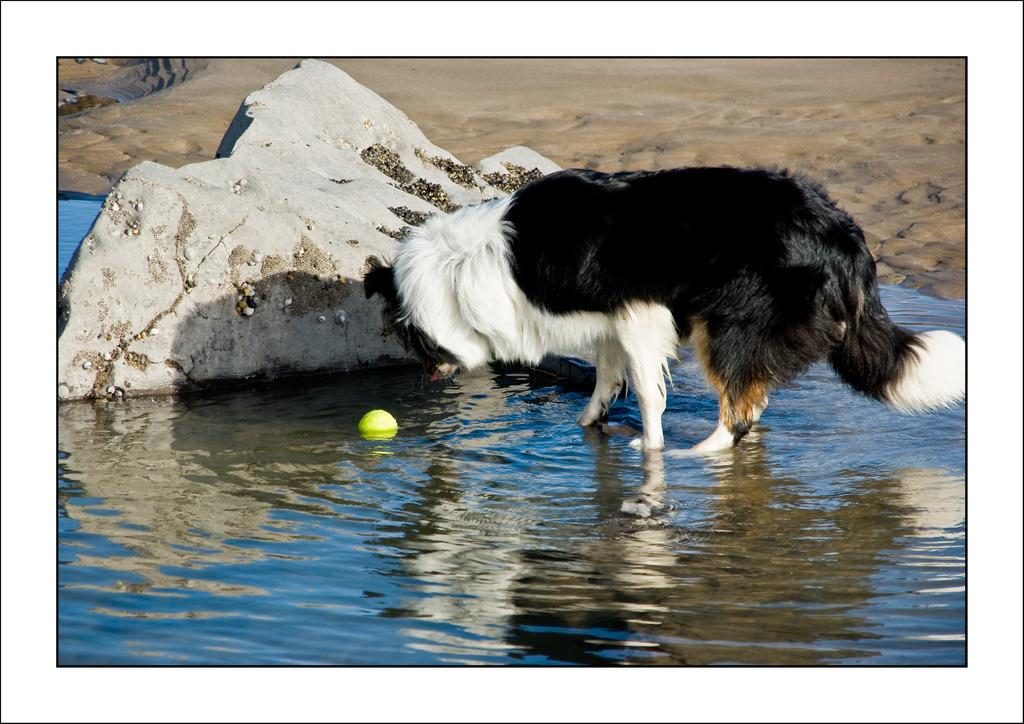What is the main subject of the image? There is a dog in the center of the image. Where is the dog located? The dog is on the water surface. What object is in front of the dog? There is a ball in front of the dog. Can you describe the object at the top side of the image? There is a stone at the top side of the image. What type of liquid is the dog swimming in? The image does not show the dog swimming; it is on the water surface. What other thing besides the dog and the ball can be seen in the image? There is no other thing besides the dog, the ball, and the stone mentioned in the facts. 